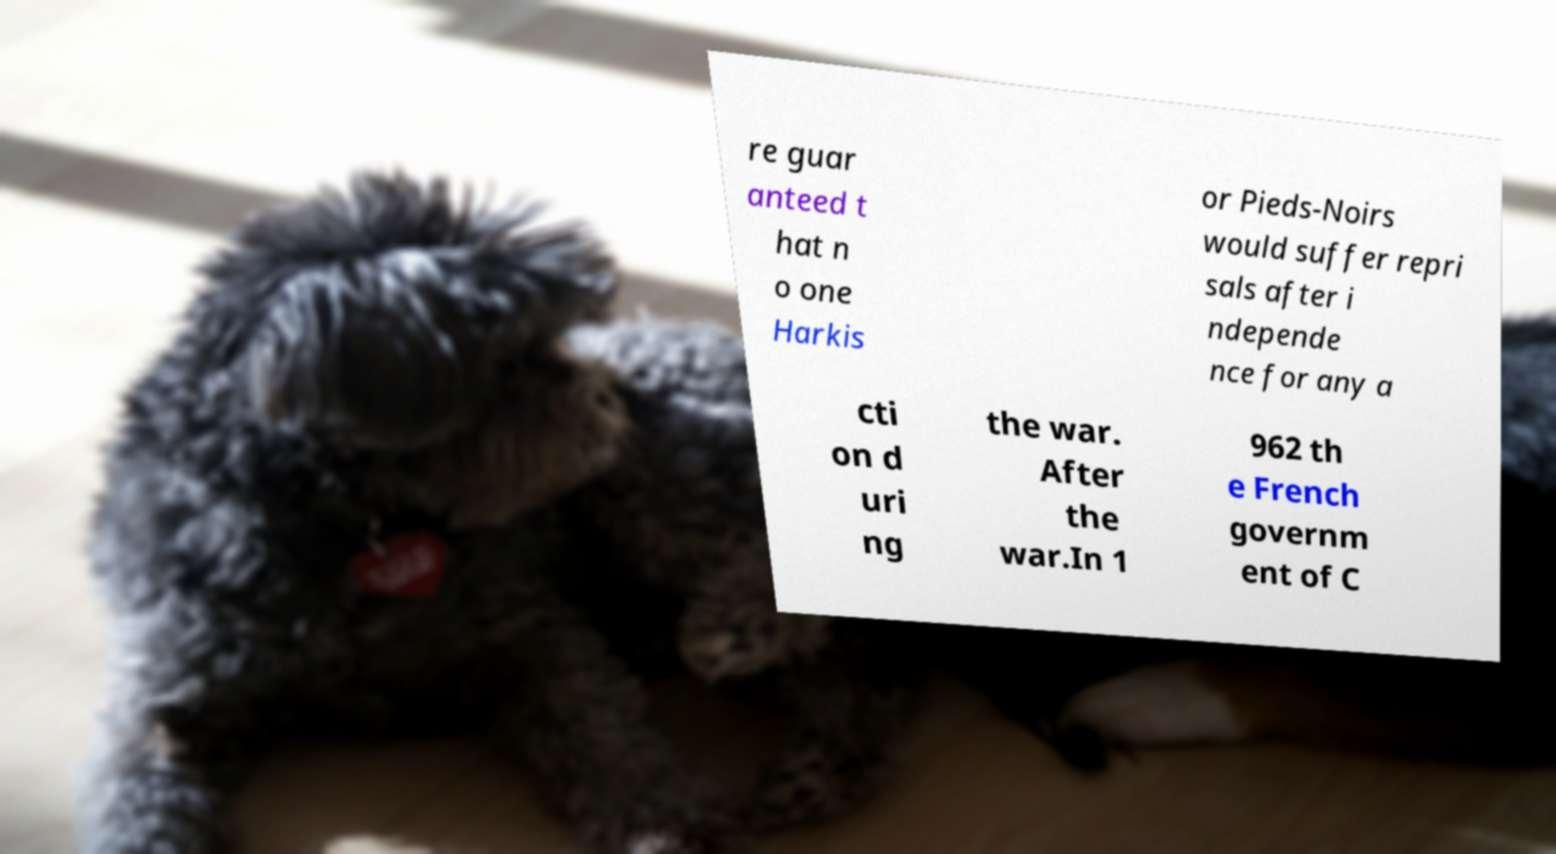For documentation purposes, I need the text within this image transcribed. Could you provide that? re guar anteed t hat n o one Harkis or Pieds-Noirs would suffer repri sals after i ndepende nce for any a cti on d uri ng the war. After the war.In 1 962 th e French governm ent of C 